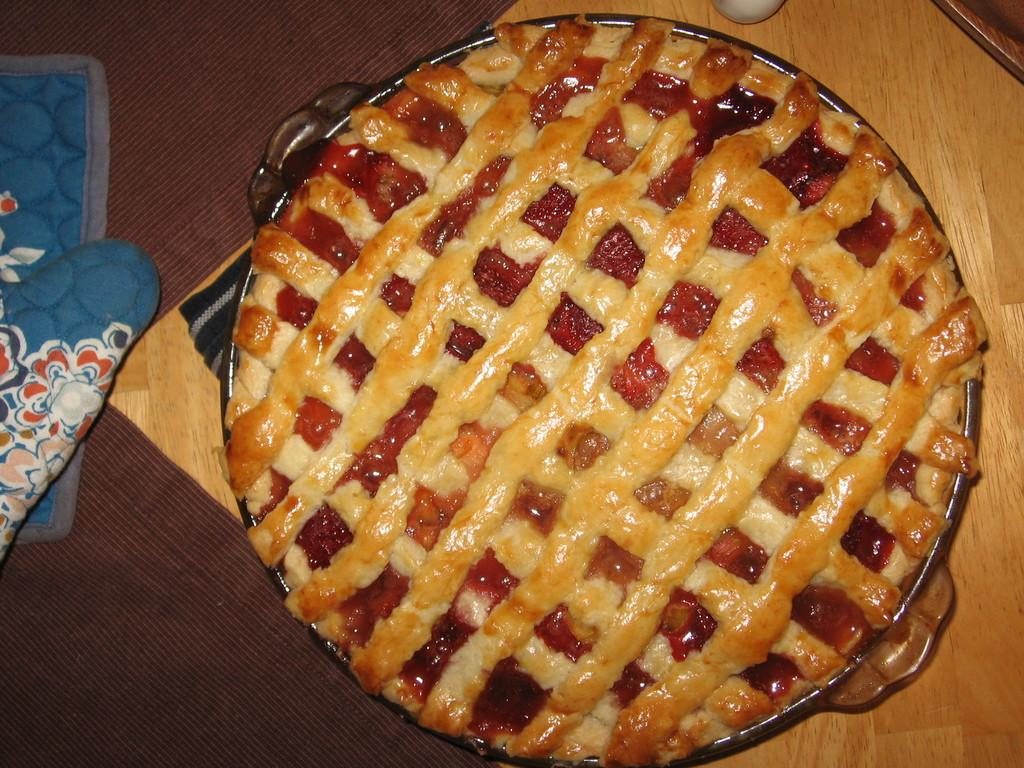What type of furniture is present in the image? There is a table in the image. What is placed on the table? There is a plate on the table. What is on the plate? There is a pizza on the plate. What song is being played on the desk in the image? There is no desk or song present in the image; it only features a table, a plate, and a pizza. 